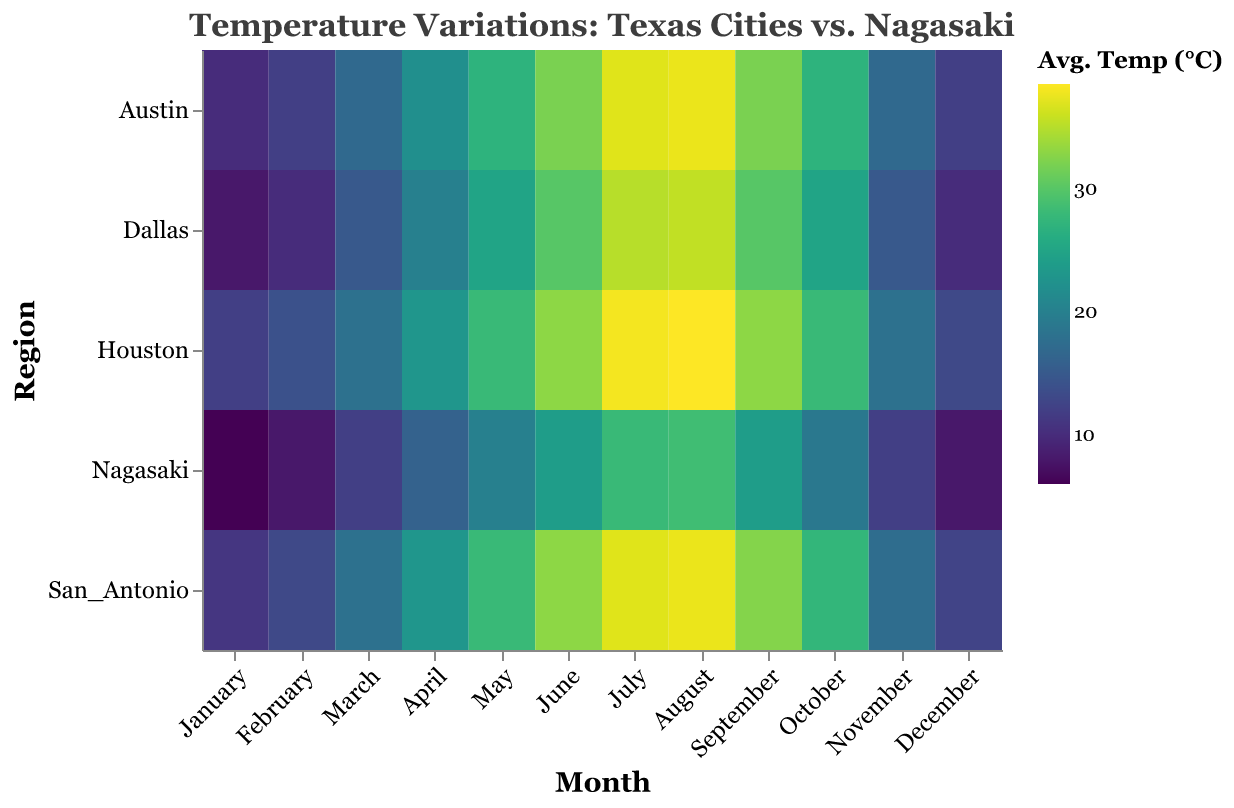What is the title of the heatmap? The title of the heatmap is directly shown at the top of the figure in a larger and styled font. Referring to the given code, the title is clearly formatted as "Temperature Variations: Texas Cities vs. Nagasaki".
Answer: Temperature Variations: Texas Cities vs. Nagasaki Which region has the highest average temperature in July? To find this, look at the row corresponding to July and identify the region with the highest value in that row. From the data, Houston has the highest temperature at 38.0°C.
Answer: Houston In which month does Nagasaki experience the lowest average temperature? To determine this, locate Nagasaki's row and find the cell with the lowest temperature value. From the data, the lowest temperature in Nagasaki is in January at 6.0°C.
Answer: January How does the average temperature in Dallas change from January to July? Check the temperature for Dallas in both January and July. In January, the temperature is 8.0°C, and in July, it is 35.0°C. The change is 35.0 - 8.0 = 27.0°C.
Answer: It increases by 27.0°C What is the average temperature difference between Houston and Austin in May? Find the temperatures for both Houston and Austin in May. Houston's temperature is 28.0°C, and Austin's temperature is 27.0°C. The difference is 28.0 - 27.0 = 1.0°C.
Answer: 1.0°C Which month shows the smallest temperature difference between San Antonio and Nagasaki? Compare the temperatures for San Antonio and Nagasaki across all months and identify the month with the smallest difference. Both cities have the smallest difference in April with a difference of 23.0 - 16.0 = 7.0°C.
Answer: April Identify the months when Nagasaki’s average temperature is higher than Dallas's. Compare Nagasaki's temperature with Dallas's across all months. Nagasaki's temperature is higher in January, February, November, and December.
Answer: January, February, November, December What is the warmest month in Austin? Examine the row for Austin and identify the month with the highest temperature value. The warmest month in Austin is August at 37.5°C.
Answer: August What is the range of temperatures experienced in Houston throughout the year? Find the minimum and maximum temperatures for Houston across all months. The lowest temperature in Houston is in January at 12.0°C, and the highest is in August at 38.5°C. The range is 38.5 - 12.0 = 26.5°C.
Answer: 26.5°C Which region experiences the highest temperature in August? Look at the row for August and identify the region with the highest temperature. Houston experiences the highest temperature in August at 38.5°C.
Answer: Houston 